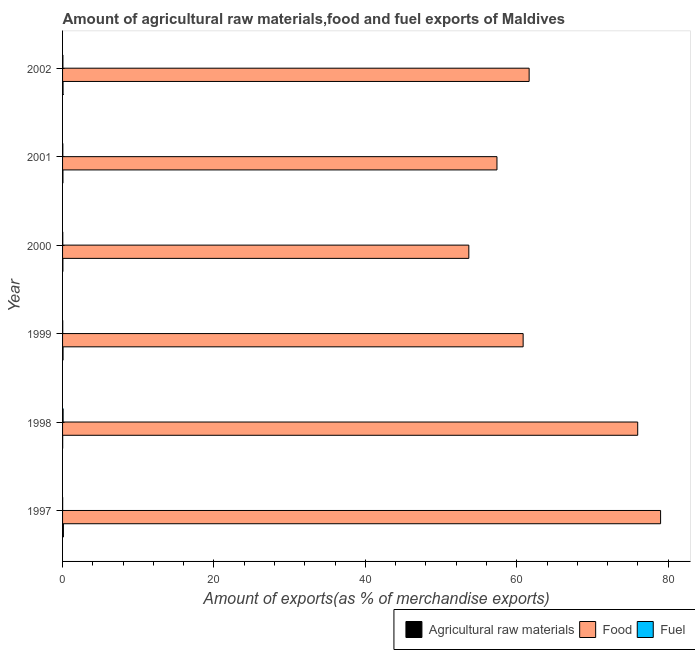How many different coloured bars are there?
Ensure brevity in your answer.  3. Are the number of bars on each tick of the Y-axis equal?
Ensure brevity in your answer.  Yes. How many bars are there on the 5th tick from the bottom?
Keep it short and to the point. 3. What is the label of the 4th group of bars from the top?
Give a very brief answer. 1999. What is the percentage of raw materials exports in 1998?
Your answer should be very brief. 0.01. Across all years, what is the maximum percentage of raw materials exports?
Make the answer very short. 0.11. Across all years, what is the minimum percentage of fuel exports?
Provide a short and direct response. 0.01. What is the total percentage of raw materials exports in the graph?
Your answer should be very brief. 0.34. What is the difference between the percentage of fuel exports in 1999 and that in 2002?
Ensure brevity in your answer.  -0.02. What is the difference between the percentage of raw materials exports in 2002 and the percentage of fuel exports in 2001?
Your answer should be compact. 0.03. What is the average percentage of food exports per year?
Keep it short and to the point. 64.75. In the year 1998, what is the difference between the percentage of food exports and percentage of raw materials exports?
Make the answer very short. 75.96. What is the ratio of the percentage of food exports in 1997 to that in 2000?
Your response must be concise. 1.47. Is the difference between the percentage of fuel exports in 1998 and 2002 greater than the difference between the percentage of raw materials exports in 1998 and 2002?
Offer a terse response. Yes. What is the difference between the highest and the second highest percentage of raw materials exports?
Make the answer very short. 0.04. What is the difference between the highest and the lowest percentage of fuel exports?
Keep it short and to the point. 0.06. In how many years, is the percentage of fuel exports greater than the average percentage of fuel exports taken over all years?
Your answer should be compact. 2. Is the sum of the percentage of food exports in 1999 and 2002 greater than the maximum percentage of raw materials exports across all years?
Offer a very short reply. Yes. What does the 3rd bar from the top in 2000 represents?
Offer a very short reply. Agricultural raw materials. What does the 1st bar from the bottom in 2002 represents?
Provide a succinct answer. Agricultural raw materials. Is it the case that in every year, the sum of the percentage of raw materials exports and percentage of food exports is greater than the percentage of fuel exports?
Give a very brief answer. Yes. How many bars are there?
Keep it short and to the point. 18. How many years are there in the graph?
Keep it short and to the point. 6. Does the graph contain any zero values?
Provide a short and direct response. No. Where does the legend appear in the graph?
Give a very brief answer. Bottom right. What is the title of the graph?
Keep it short and to the point. Amount of agricultural raw materials,food and fuel exports of Maldives. What is the label or title of the X-axis?
Provide a succinct answer. Amount of exports(as % of merchandise exports). What is the Amount of exports(as % of merchandise exports) in Agricultural raw materials in 1997?
Your response must be concise. 0.11. What is the Amount of exports(as % of merchandise exports) of Food in 1997?
Your answer should be compact. 79. What is the Amount of exports(as % of merchandise exports) of Fuel in 1997?
Your answer should be very brief. 0.01. What is the Amount of exports(as % of merchandise exports) in Agricultural raw materials in 1998?
Your answer should be compact. 0.01. What is the Amount of exports(as % of merchandise exports) of Food in 1998?
Your answer should be compact. 75.97. What is the Amount of exports(as % of merchandise exports) of Fuel in 1998?
Your response must be concise. 0.07. What is the Amount of exports(as % of merchandise exports) of Agricultural raw materials in 1999?
Your answer should be compact. 0.06. What is the Amount of exports(as % of merchandise exports) of Food in 1999?
Offer a very short reply. 60.84. What is the Amount of exports(as % of merchandise exports) in Fuel in 1999?
Your answer should be compact. 0.02. What is the Amount of exports(as % of merchandise exports) in Agricultural raw materials in 2000?
Your response must be concise. 0.04. What is the Amount of exports(as % of merchandise exports) of Food in 2000?
Give a very brief answer. 53.67. What is the Amount of exports(as % of merchandise exports) in Fuel in 2000?
Ensure brevity in your answer.  0.03. What is the Amount of exports(as % of merchandise exports) in Agricultural raw materials in 2001?
Offer a very short reply. 0.05. What is the Amount of exports(as % of merchandise exports) of Food in 2001?
Offer a terse response. 57.38. What is the Amount of exports(as % of merchandise exports) in Fuel in 2001?
Offer a terse response. 0.03. What is the Amount of exports(as % of merchandise exports) of Agricultural raw materials in 2002?
Your answer should be very brief. 0.06. What is the Amount of exports(as % of merchandise exports) in Food in 2002?
Make the answer very short. 61.63. What is the Amount of exports(as % of merchandise exports) of Fuel in 2002?
Ensure brevity in your answer.  0.05. Across all years, what is the maximum Amount of exports(as % of merchandise exports) of Agricultural raw materials?
Keep it short and to the point. 0.11. Across all years, what is the maximum Amount of exports(as % of merchandise exports) in Food?
Offer a terse response. 79. Across all years, what is the maximum Amount of exports(as % of merchandise exports) of Fuel?
Keep it short and to the point. 0.07. Across all years, what is the minimum Amount of exports(as % of merchandise exports) in Agricultural raw materials?
Give a very brief answer. 0.01. Across all years, what is the minimum Amount of exports(as % of merchandise exports) in Food?
Provide a short and direct response. 53.67. Across all years, what is the minimum Amount of exports(as % of merchandise exports) in Fuel?
Offer a terse response. 0.01. What is the total Amount of exports(as % of merchandise exports) of Agricultural raw materials in the graph?
Offer a very short reply. 0.34. What is the total Amount of exports(as % of merchandise exports) in Food in the graph?
Give a very brief answer. 388.49. What is the total Amount of exports(as % of merchandise exports) of Fuel in the graph?
Your answer should be compact. 0.22. What is the difference between the Amount of exports(as % of merchandise exports) in Agricultural raw materials in 1997 and that in 1998?
Offer a terse response. 0.09. What is the difference between the Amount of exports(as % of merchandise exports) in Food in 1997 and that in 1998?
Keep it short and to the point. 3.02. What is the difference between the Amount of exports(as % of merchandise exports) in Fuel in 1997 and that in 1998?
Offer a terse response. -0.06. What is the difference between the Amount of exports(as % of merchandise exports) in Agricultural raw materials in 1997 and that in 1999?
Make the answer very short. 0.04. What is the difference between the Amount of exports(as % of merchandise exports) of Food in 1997 and that in 1999?
Offer a very short reply. 18.16. What is the difference between the Amount of exports(as % of merchandise exports) in Fuel in 1997 and that in 1999?
Provide a succinct answer. -0.01. What is the difference between the Amount of exports(as % of merchandise exports) in Agricultural raw materials in 1997 and that in 2000?
Offer a very short reply. 0.07. What is the difference between the Amount of exports(as % of merchandise exports) in Food in 1997 and that in 2000?
Ensure brevity in your answer.  25.33. What is the difference between the Amount of exports(as % of merchandise exports) of Fuel in 1997 and that in 2000?
Offer a terse response. -0.02. What is the difference between the Amount of exports(as % of merchandise exports) of Agricultural raw materials in 1997 and that in 2001?
Your answer should be compact. 0.06. What is the difference between the Amount of exports(as % of merchandise exports) of Food in 1997 and that in 2001?
Offer a very short reply. 21.61. What is the difference between the Amount of exports(as % of merchandise exports) in Fuel in 1997 and that in 2001?
Provide a short and direct response. -0.02. What is the difference between the Amount of exports(as % of merchandise exports) of Agricultural raw materials in 1997 and that in 2002?
Offer a very short reply. 0.04. What is the difference between the Amount of exports(as % of merchandise exports) in Food in 1997 and that in 2002?
Provide a succinct answer. 17.36. What is the difference between the Amount of exports(as % of merchandise exports) in Fuel in 1997 and that in 2002?
Your response must be concise. -0.03. What is the difference between the Amount of exports(as % of merchandise exports) of Agricultural raw materials in 1998 and that in 1999?
Your answer should be very brief. -0.05. What is the difference between the Amount of exports(as % of merchandise exports) of Food in 1998 and that in 1999?
Make the answer very short. 15.13. What is the difference between the Amount of exports(as % of merchandise exports) in Fuel in 1998 and that in 1999?
Ensure brevity in your answer.  0.05. What is the difference between the Amount of exports(as % of merchandise exports) of Agricultural raw materials in 1998 and that in 2000?
Offer a very short reply. -0.03. What is the difference between the Amount of exports(as % of merchandise exports) in Food in 1998 and that in 2000?
Keep it short and to the point. 22.31. What is the difference between the Amount of exports(as % of merchandise exports) in Fuel in 1998 and that in 2000?
Offer a very short reply. 0.04. What is the difference between the Amount of exports(as % of merchandise exports) in Agricultural raw materials in 1998 and that in 2001?
Your answer should be compact. -0.04. What is the difference between the Amount of exports(as % of merchandise exports) of Food in 1998 and that in 2001?
Offer a terse response. 18.59. What is the difference between the Amount of exports(as % of merchandise exports) in Fuel in 1998 and that in 2001?
Give a very brief answer. 0.04. What is the difference between the Amount of exports(as % of merchandise exports) of Agricultural raw materials in 1998 and that in 2002?
Ensure brevity in your answer.  -0.05. What is the difference between the Amount of exports(as % of merchandise exports) of Food in 1998 and that in 2002?
Make the answer very short. 14.34. What is the difference between the Amount of exports(as % of merchandise exports) in Fuel in 1998 and that in 2002?
Keep it short and to the point. 0.03. What is the difference between the Amount of exports(as % of merchandise exports) of Agricultural raw materials in 1999 and that in 2000?
Your answer should be compact. 0.02. What is the difference between the Amount of exports(as % of merchandise exports) in Food in 1999 and that in 2000?
Offer a terse response. 7.17. What is the difference between the Amount of exports(as % of merchandise exports) of Fuel in 1999 and that in 2000?
Make the answer very short. -0.01. What is the difference between the Amount of exports(as % of merchandise exports) of Agricultural raw materials in 1999 and that in 2001?
Keep it short and to the point. 0.01. What is the difference between the Amount of exports(as % of merchandise exports) in Food in 1999 and that in 2001?
Ensure brevity in your answer.  3.46. What is the difference between the Amount of exports(as % of merchandise exports) in Fuel in 1999 and that in 2001?
Your answer should be compact. -0.01. What is the difference between the Amount of exports(as % of merchandise exports) in Agricultural raw materials in 1999 and that in 2002?
Provide a short and direct response. -0. What is the difference between the Amount of exports(as % of merchandise exports) of Food in 1999 and that in 2002?
Keep it short and to the point. -0.79. What is the difference between the Amount of exports(as % of merchandise exports) in Fuel in 1999 and that in 2002?
Make the answer very short. -0.02. What is the difference between the Amount of exports(as % of merchandise exports) in Agricultural raw materials in 2000 and that in 2001?
Offer a very short reply. -0.01. What is the difference between the Amount of exports(as % of merchandise exports) of Food in 2000 and that in 2001?
Offer a very short reply. -3.72. What is the difference between the Amount of exports(as % of merchandise exports) of Fuel in 2000 and that in 2001?
Give a very brief answer. -0.01. What is the difference between the Amount of exports(as % of merchandise exports) of Agricultural raw materials in 2000 and that in 2002?
Provide a succinct answer. -0.02. What is the difference between the Amount of exports(as % of merchandise exports) in Food in 2000 and that in 2002?
Give a very brief answer. -7.97. What is the difference between the Amount of exports(as % of merchandise exports) in Fuel in 2000 and that in 2002?
Provide a succinct answer. -0.02. What is the difference between the Amount of exports(as % of merchandise exports) in Agricultural raw materials in 2001 and that in 2002?
Make the answer very short. -0.01. What is the difference between the Amount of exports(as % of merchandise exports) of Food in 2001 and that in 2002?
Ensure brevity in your answer.  -4.25. What is the difference between the Amount of exports(as % of merchandise exports) of Fuel in 2001 and that in 2002?
Your answer should be very brief. -0.01. What is the difference between the Amount of exports(as % of merchandise exports) of Agricultural raw materials in 1997 and the Amount of exports(as % of merchandise exports) of Food in 1998?
Your answer should be compact. -75.87. What is the difference between the Amount of exports(as % of merchandise exports) in Agricultural raw materials in 1997 and the Amount of exports(as % of merchandise exports) in Fuel in 1998?
Keep it short and to the point. 0.04. What is the difference between the Amount of exports(as % of merchandise exports) of Food in 1997 and the Amount of exports(as % of merchandise exports) of Fuel in 1998?
Keep it short and to the point. 78.92. What is the difference between the Amount of exports(as % of merchandise exports) in Agricultural raw materials in 1997 and the Amount of exports(as % of merchandise exports) in Food in 1999?
Give a very brief answer. -60.73. What is the difference between the Amount of exports(as % of merchandise exports) in Agricultural raw materials in 1997 and the Amount of exports(as % of merchandise exports) in Fuel in 1999?
Your response must be concise. 0.08. What is the difference between the Amount of exports(as % of merchandise exports) in Food in 1997 and the Amount of exports(as % of merchandise exports) in Fuel in 1999?
Provide a succinct answer. 78.97. What is the difference between the Amount of exports(as % of merchandise exports) in Agricultural raw materials in 1997 and the Amount of exports(as % of merchandise exports) in Food in 2000?
Your answer should be compact. -53.56. What is the difference between the Amount of exports(as % of merchandise exports) in Agricultural raw materials in 1997 and the Amount of exports(as % of merchandise exports) in Fuel in 2000?
Your answer should be very brief. 0.08. What is the difference between the Amount of exports(as % of merchandise exports) in Food in 1997 and the Amount of exports(as % of merchandise exports) in Fuel in 2000?
Provide a succinct answer. 78.97. What is the difference between the Amount of exports(as % of merchandise exports) of Agricultural raw materials in 1997 and the Amount of exports(as % of merchandise exports) of Food in 2001?
Offer a very short reply. -57.28. What is the difference between the Amount of exports(as % of merchandise exports) of Agricultural raw materials in 1997 and the Amount of exports(as % of merchandise exports) of Fuel in 2001?
Give a very brief answer. 0.07. What is the difference between the Amount of exports(as % of merchandise exports) in Food in 1997 and the Amount of exports(as % of merchandise exports) in Fuel in 2001?
Give a very brief answer. 78.96. What is the difference between the Amount of exports(as % of merchandise exports) of Agricultural raw materials in 1997 and the Amount of exports(as % of merchandise exports) of Food in 2002?
Offer a very short reply. -61.52. What is the difference between the Amount of exports(as % of merchandise exports) in Agricultural raw materials in 1997 and the Amount of exports(as % of merchandise exports) in Fuel in 2002?
Provide a short and direct response. 0.06. What is the difference between the Amount of exports(as % of merchandise exports) in Food in 1997 and the Amount of exports(as % of merchandise exports) in Fuel in 2002?
Ensure brevity in your answer.  78.95. What is the difference between the Amount of exports(as % of merchandise exports) of Agricultural raw materials in 1998 and the Amount of exports(as % of merchandise exports) of Food in 1999?
Provide a succinct answer. -60.83. What is the difference between the Amount of exports(as % of merchandise exports) of Agricultural raw materials in 1998 and the Amount of exports(as % of merchandise exports) of Fuel in 1999?
Provide a succinct answer. -0.01. What is the difference between the Amount of exports(as % of merchandise exports) in Food in 1998 and the Amount of exports(as % of merchandise exports) in Fuel in 1999?
Offer a terse response. 75.95. What is the difference between the Amount of exports(as % of merchandise exports) of Agricultural raw materials in 1998 and the Amount of exports(as % of merchandise exports) of Food in 2000?
Your answer should be compact. -53.65. What is the difference between the Amount of exports(as % of merchandise exports) of Agricultural raw materials in 1998 and the Amount of exports(as % of merchandise exports) of Fuel in 2000?
Offer a terse response. -0.02. What is the difference between the Amount of exports(as % of merchandise exports) in Food in 1998 and the Amount of exports(as % of merchandise exports) in Fuel in 2000?
Provide a succinct answer. 75.94. What is the difference between the Amount of exports(as % of merchandise exports) in Agricultural raw materials in 1998 and the Amount of exports(as % of merchandise exports) in Food in 2001?
Your answer should be very brief. -57.37. What is the difference between the Amount of exports(as % of merchandise exports) in Agricultural raw materials in 1998 and the Amount of exports(as % of merchandise exports) in Fuel in 2001?
Your response must be concise. -0.02. What is the difference between the Amount of exports(as % of merchandise exports) in Food in 1998 and the Amount of exports(as % of merchandise exports) in Fuel in 2001?
Your response must be concise. 75.94. What is the difference between the Amount of exports(as % of merchandise exports) in Agricultural raw materials in 1998 and the Amount of exports(as % of merchandise exports) in Food in 2002?
Make the answer very short. -61.62. What is the difference between the Amount of exports(as % of merchandise exports) of Agricultural raw materials in 1998 and the Amount of exports(as % of merchandise exports) of Fuel in 2002?
Your answer should be compact. -0.03. What is the difference between the Amount of exports(as % of merchandise exports) of Food in 1998 and the Amount of exports(as % of merchandise exports) of Fuel in 2002?
Ensure brevity in your answer.  75.93. What is the difference between the Amount of exports(as % of merchandise exports) in Agricultural raw materials in 1999 and the Amount of exports(as % of merchandise exports) in Food in 2000?
Provide a short and direct response. -53.6. What is the difference between the Amount of exports(as % of merchandise exports) in Agricultural raw materials in 1999 and the Amount of exports(as % of merchandise exports) in Fuel in 2000?
Provide a short and direct response. 0.03. What is the difference between the Amount of exports(as % of merchandise exports) of Food in 1999 and the Amount of exports(as % of merchandise exports) of Fuel in 2000?
Your response must be concise. 60.81. What is the difference between the Amount of exports(as % of merchandise exports) in Agricultural raw materials in 1999 and the Amount of exports(as % of merchandise exports) in Food in 2001?
Make the answer very short. -57.32. What is the difference between the Amount of exports(as % of merchandise exports) in Agricultural raw materials in 1999 and the Amount of exports(as % of merchandise exports) in Fuel in 2001?
Offer a terse response. 0.03. What is the difference between the Amount of exports(as % of merchandise exports) in Food in 1999 and the Amount of exports(as % of merchandise exports) in Fuel in 2001?
Provide a short and direct response. 60.81. What is the difference between the Amount of exports(as % of merchandise exports) of Agricultural raw materials in 1999 and the Amount of exports(as % of merchandise exports) of Food in 2002?
Your answer should be very brief. -61.57. What is the difference between the Amount of exports(as % of merchandise exports) of Agricultural raw materials in 1999 and the Amount of exports(as % of merchandise exports) of Fuel in 2002?
Offer a very short reply. 0.02. What is the difference between the Amount of exports(as % of merchandise exports) in Food in 1999 and the Amount of exports(as % of merchandise exports) in Fuel in 2002?
Offer a terse response. 60.79. What is the difference between the Amount of exports(as % of merchandise exports) in Agricultural raw materials in 2000 and the Amount of exports(as % of merchandise exports) in Food in 2001?
Make the answer very short. -57.34. What is the difference between the Amount of exports(as % of merchandise exports) in Agricultural raw materials in 2000 and the Amount of exports(as % of merchandise exports) in Fuel in 2001?
Make the answer very short. 0.01. What is the difference between the Amount of exports(as % of merchandise exports) in Food in 2000 and the Amount of exports(as % of merchandise exports) in Fuel in 2001?
Keep it short and to the point. 53.63. What is the difference between the Amount of exports(as % of merchandise exports) in Agricultural raw materials in 2000 and the Amount of exports(as % of merchandise exports) in Food in 2002?
Your response must be concise. -61.59. What is the difference between the Amount of exports(as % of merchandise exports) of Agricultural raw materials in 2000 and the Amount of exports(as % of merchandise exports) of Fuel in 2002?
Give a very brief answer. -0. What is the difference between the Amount of exports(as % of merchandise exports) in Food in 2000 and the Amount of exports(as % of merchandise exports) in Fuel in 2002?
Ensure brevity in your answer.  53.62. What is the difference between the Amount of exports(as % of merchandise exports) in Agricultural raw materials in 2001 and the Amount of exports(as % of merchandise exports) in Food in 2002?
Ensure brevity in your answer.  -61.58. What is the difference between the Amount of exports(as % of merchandise exports) of Agricultural raw materials in 2001 and the Amount of exports(as % of merchandise exports) of Fuel in 2002?
Provide a succinct answer. 0. What is the difference between the Amount of exports(as % of merchandise exports) of Food in 2001 and the Amount of exports(as % of merchandise exports) of Fuel in 2002?
Make the answer very short. 57.34. What is the average Amount of exports(as % of merchandise exports) of Agricultural raw materials per year?
Give a very brief answer. 0.06. What is the average Amount of exports(as % of merchandise exports) in Food per year?
Make the answer very short. 64.75. What is the average Amount of exports(as % of merchandise exports) of Fuel per year?
Make the answer very short. 0.04. In the year 1997, what is the difference between the Amount of exports(as % of merchandise exports) of Agricultural raw materials and Amount of exports(as % of merchandise exports) of Food?
Offer a terse response. -78.89. In the year 1997, what is the difference between the Amount of exports(as % of merchandise exports) of Agricultural raw materials and Amount of exports(as % of merchandise exports) of Fuel?
Keep it short and to the point. 0.1. In the year 1997, what is the difference between the Amount of exports(as % of merchandise exports) of Food and Amount of exports(as % of merchandise exports) of Fuel?
Make the answer very short. 78.98. In the year 1998, what is the difference between the Amount of exports(as % of merchandise exports) in Agricultural raw materials and Amount of exports(as % of merchandise exports) in Food?
Give a very brief answer. -75.96. In the year 1998, what is the difference between the Amount of exports(as % of merchandise exports) of Agricultural raw materials and Amount of exports(as % of merchandise exports) of Fuel?
Give a very brief answer. -0.06. In the year 1998, what is the difference between the Amount of exports(as % of merchandise exports) of Food and Amount of exports(as % of merchandise exports) of Fuel?
Your answer should be very brief. 75.9. In the year 1999, what is the difference between the Amount of exports(as % of merchandise exports) of Agricultural raw materials and Amount of exports(as % of merchandise exports) of Food?
Provide a succinct answer. -60.78. In the year 1999, what is the difference between the Amount of exports(as % of merchandise exports) of Agricultural raw materials and Amount of exports(as % of merchandise exports) of Fuel?
Your answer should be compact. 0.04. In the year 1999, what is the difference between the Amount of exports(as % of merchandise exports) in Food and Amount of exports(as % of merchandise exports) in Fuel?
Offer a terse response. 60.82. In the year 2000, what is the difference between the Amount of exports(as % of merchandise exports) of Agricultural raw materials and Amount of exports(as % of merchandise exports) of Food?
Your answer should be very brief. -53.62. In the year 2000, what is the difference between the Amount of exports(as % of merchandise exports) of Agricultural raw materials and Amount of exports(as % of merchandise exports) of Fuel?
Ensure brevity in your answer.  0.01. In the year 2000, what is the difference between the Amount of exports(as % of merchandise exports) in Food and Amount of exports(as % of merchandise exports) in Fuel?
Offer a terse response. 53.64. In the year 2001, what is the difference between the Amount of exports(as % of merchandise exports) in Agricultural raw materials and Amount of exports(as % of merchandise exports) in Food?
Provide a short and direct response. -57.33. In the year 2001, what is the difference between the Amount of exports(as % of merchandise exports) of Agricultural raw materials and Amount of exports(as % of merchandise exports) of Fuel?
Provide a succinct answer. 0.02. In the year 2001, what is the difference between the Amount of exports(as % of merchandise exports) of Food and Amount of exports(as % of merchandise exports) of Fuel?
Ensure brevity in your answer.  57.35. In the year 2002, what is the difference between the Amount of exports(as % of merchandise exports) of Agricultural raw materials and Amount of exports(as % of merchandise exports) of Food?
Your answer should be compact. -61.57. In the year 2002, what is the difference between the Amount of exports(as % of merchandise exports) of Agricultural raw materials and Amount of exports(as % of merchandise exports) of Fuel?
Keep it short and to the point. 0.02. In the year 2002, what is the difference between the Amount of exports(as % of merchandise exports) in Food and Amount of exports(as % of merchandise exports) in Fuel?
Your response must be concise. 61.59. What is the ratio of the Amount of exports(as % of merchandise exports) in Agricultural raw materials in 1997 to that in 1998?
Your response must be concise. 7.83. What is the ratio of the Amount of exports(as % of merchandise exports) in Food in 1997 to that in 1998?
Ensure brevity in your answer.  1.04. What is the ratio of the Amount of exports(as % of merchandise exports) in Fuel in 1997 to that in 1998?
Your answer should be compact. 0.18. What is the ratio of the Amount of exports(as % of merchandise exports) of Agricultural raw materials in 1997 to that in 1999?
Provide a succinct answer. 1.7. What is the ratio of the Amount of exports(as % of merchandise exports) in Food in 1997 to that in 1999?
Your answer should be compact. 1.3. What is the ratio of the Amount of exports(as % of merchandise exports) in Fuel in 1997 to that in 1999?
Make the answer very short. 0.55. What is the ratio of the Amount of exports(as % of merchandise exports) of Agricultural raw materials in 1997 to that in 2000?
Keep it short and to the point. 2.55. What is the ratio of the Amount of exports(as % of merchandise exports) of Food in 1997 to that in 2000?
Keep it short and to the point. 1.47. What is the ratio of the Amount of exports(as % of merchandise exports) in Fuel in 1997 to that in 2000?
Offer a terse response. 0.44. What is the ratio of the Amount of exports(as % of merchandise exports) of Agricultural raw materials in 1997 to that in 2001?
Offer a terse response. 2.18. What is the ratio of the Amount of exports(as % of merchandise exports) of Food in 1997 to that in 2001?
Give a very brief answer. 1.38. What is the ratio of the Amount of exports(as % of merchandise exports) of Fuel in 1997 to that in 2001?
Your answer should be very brief. 0.37. What is the ratio of the Amount of exports(as % of merchandise exports) in Agricultural raw materials in 1997 to that in 2002?
Offer a terse response. 1.7. What is the ratio of the Amount of exports(as % of merchandise exports) of Food in 1997 to that in 2002?
Keep it short and to the point. 1.28. What is the ratio of the Amount of exports(as % of merchandise exports) in Fuel in 1997 to that in 2002?
Your answer should be very brief. 0.27. What is the ratio of the Amount of exports(as % of merchandise exports) of Agricultural raw materials in 1998 to that in 1999?
Offer a terse response. 0.22. What is the ratio of the Amount of exports(as % of merchandise exports) of Food in 1998 to that in 1999?
Your answer should be compact. 1.25. What is the ratio of the Amount of exports(as % of merchandise exports) of Fuel in 1998 to that in 1999?
Provide a succinct answer. 3.12. What is the ratio of the Amount of exports(as % of merchandise exports) in Agricultural raw materials in 1998 to that in 2000?
Provide a succinct answer. 0.33. What is the ratio of the Amount of exports(as % of merchandise exports) of Food in 1998 to that in 2000?
Ensure brevity in your answer.  1.42. What is the ratio of the Amount of exports(as % of merchandise exports) of Fuel in 1998 to that in 2000?
Offer a terse response. 2.48. What is the ratio of the Amount of exports(as % of merchandise exports) of Agricultural raw materials in 1998 to that in 2001?
Your answer should be very brief. 0.28. What is the ratio of the Amount of exports(as % of merchandise exports) in Food in 1998 to that in 2001?
Your response must be concise. 1.32. What is the ratio of the Amount of exports(as % of merchandise exports) of Fuel in 1998 to that in 2001?
Provide a succinct answer. 2.11. What is the ratio of the Amount of exports(as % of merchandise exports) in Agricultural raw materials in 1998 to that in 2002?
Give a very brief answer. 0.22. What is the ratio of the Amount of exports(as % of merchandise exports) in Food in 1998 to that in 2002?
Offer a very short reply. 1.23. What is the ratio of the Amount of exports(as % of merchandise exports) of Fuel in 1998 to that in 2002?
Your response must be concise. 1.56. What is the ratio of the Amount of exports(as % of merchandise exports) of Agricultural raw materials in 1999 to that in 2000?
Offer a terse response. 1.5. What is the ratio of the Amount of exports(as % of merchandise exports) of Food in 1999 to that in 2000?
Offer a very short reply. 1.13. What is the ratio of the Amount of exports(as % of merchandise exports) of Fuel in 1999 to that in 2000?
Keep it short and to the point. 0.8. What is the ratio of the Amount of exports(as % of merchandise exports) of Agricultural raw materials in 1999 to that in 2001?
Your answer should be compact. 1.28. What is the ratio of the Amount of exports(as % of merchandise exports) in Food in 1999 to that in 2001?
Your response must be concise. 1.06. What is the ratio of the Amount of exports(as % of merchandise exports) of Fuel in 1999 to that in 2001?
Offer a terse response. 0.68. What is the ratio of the Amount of exports(as % of merchandise exports) in Food in 1999 to that in 2002?
Your answer should be very brief. 0.99. What is the ratio of the Amount of exports(as % of merchandise exports) in Fuel in 1999 to that in 2002?
Your answer should be very brief. 0.5. What is the ratio of the Amount of exports(as % of merchandise exports) of Agricultural raw materials in 2000 to that in 2001?
Give a very brief answer. 0.86. What is the ratio of the Amount of exports(as % of merchandise exports) in Food in 2000 to that in 2001?
Your answer should be very brief. 0.94. What is the ratio of the Amount of exports(as % of merchandise exports) in Fuel in 2000 to that in 2001?
Offer a very short reply. 0.85. What is the ratio of the Amount of exports(as % of merchandise exports) of Agricultural raw materials in 2000 to that in 2002?
Offer a very short reply. 0.67. What is the ratio of the Amount of exports(as % of merchandise exports) of Food in 2000 to that in 2002?
Offer a terse response. 0.87. What is the ratio of the Amount of exports(as % of merchandise exports) of Fuel in 2000 to that in 2002?
Your response must be concise. 0.63. What is the ratio of the Amount of exports(as % of merchandise exports) in Agricultural raw materials in 2001 to that in 2002?
Offer a very short reply. 0.78. What is the ratio of the Amount of exports(as % of merchandise exports) in Food in 2001 to that in 2002?
Your answer should be compact. 0.93. What is the ratio of the Amount of exports(as % of merchandise exports) in Fuel in 2001 to that in 2002?
Make the answer very short. 0.74. What is the difference between the highest and the second highest Amount of exports(as % of merchandise exports) of Agricultural raw materials?
Make the answer very short. 0.04. What is the difference between the highest and the second highest Amount of exports(as % of merchandise exports) of Food?
Your answer should be very brief. 3.02. What is the difference between the highest and the second highest Amount of exports(as % of merchandise exports) of Fuel?
Ensure brevity in your answer.  0.03. What is the difference between the highest and the lowest Amount of exports(as % of merchandise exports) of Agricultural raw materials?
Make the answer very short. 0.09. What is the difference between the highest and the lowest Amount of exports(as % of merchandise exports) in Food?
Give a very brief answer. 25.33. What is the difference between the highest and the lowest Amount of exports(as % of merchandise exports) in Fuel?
Offer a very short reply. 0.06. 